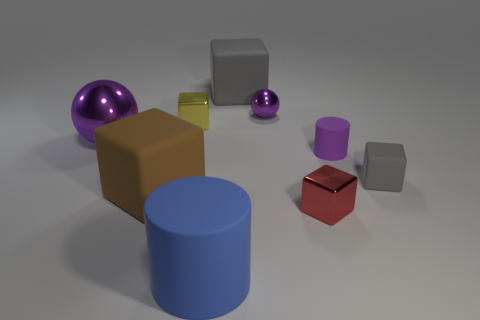Subtract all purple balls. How many were subtracted if there are1purple balls left? 1 Subtract 2 blocks. How many blocks are left? 3 Subtract all yellow blocks. How many blocks are left? 4 Subtract all tiny red shiny cubes. How many cubes are left? 4 Subtract all red balls. Subtract all cyan blocks. How many balls are left? 2 Subtract all cubes. How many objects are left? 4 Subtract 1 red cubes. How many objects are left? 8 Subtract all tiny cyan matte cylinders. Subtract all balls. How many objects are left? 7 Add 4 small objects. How many small objects are left? 9 Add 4 tiny red shiny blocks. How many tiny red shiny blocks exist? 5 